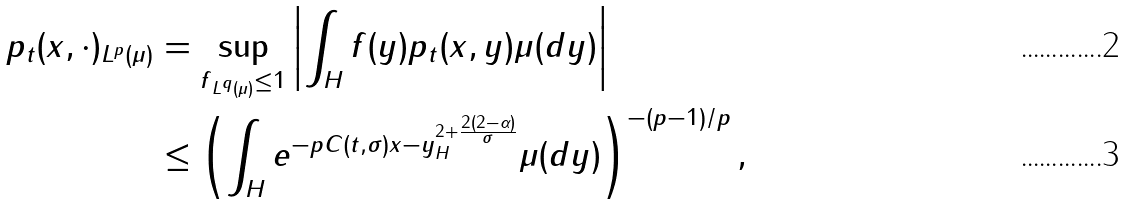Convert formula to latex. <formula><loc_0><loc_0><loc_500><loc_500>\| p _ { t } ( x , \cdot ) \| _ { L ^ { p } ( \mu ) } & = \sup _ { \| f \| _ { L ^ { q } ( \mu ) } \leq 1 } \left | \int _ { H } f ( y ) p _ { t } ( x , y ) \mu ( d y ) \right | \\ & \leq \left ( \int _ { H } e ^ { - p C ( t , \sigma ) \| x - y \| _ { H } ^ { 2 + \frac { 2 ( 2 - \alpha ) } { \sigma } } } \mu ( d y ) \right ) ^ { - ( p - 1 ) / p } ,</formula> 